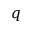<formula> <loc_0><loc_0><loc_500><loc_500>q</formula> 